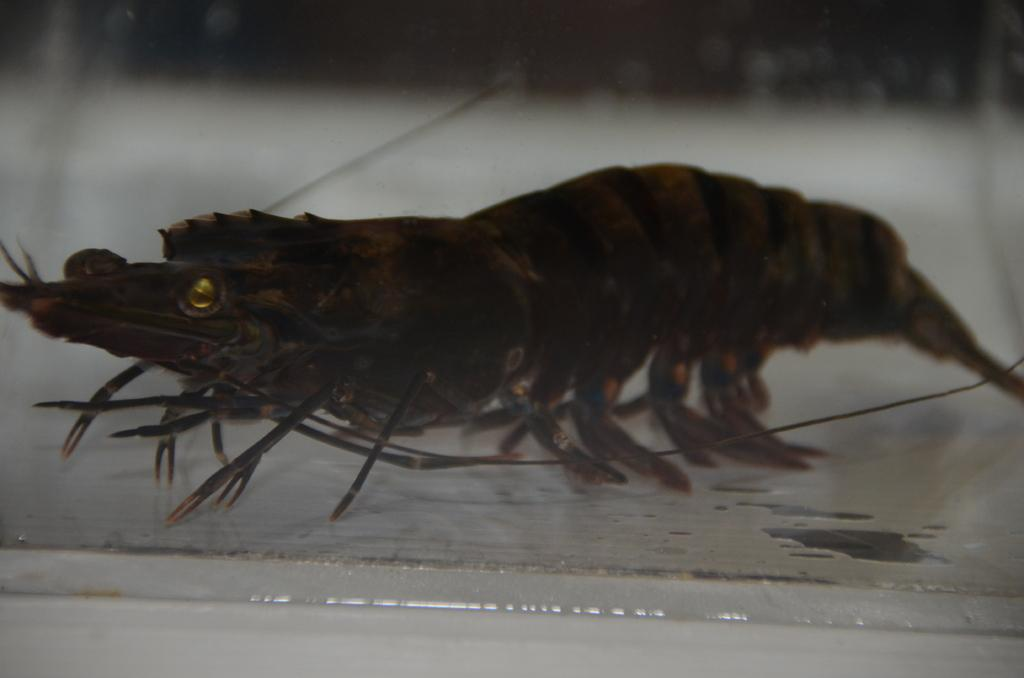What type of seafood is present in the image? There is a shrimp in the image. What is the shrimp resting on or attached to? The shrimp is on an object. What type of letters can be seen on the zebra in the image? There is no zebra present in the image, and therefore no letters can be seen on it. 